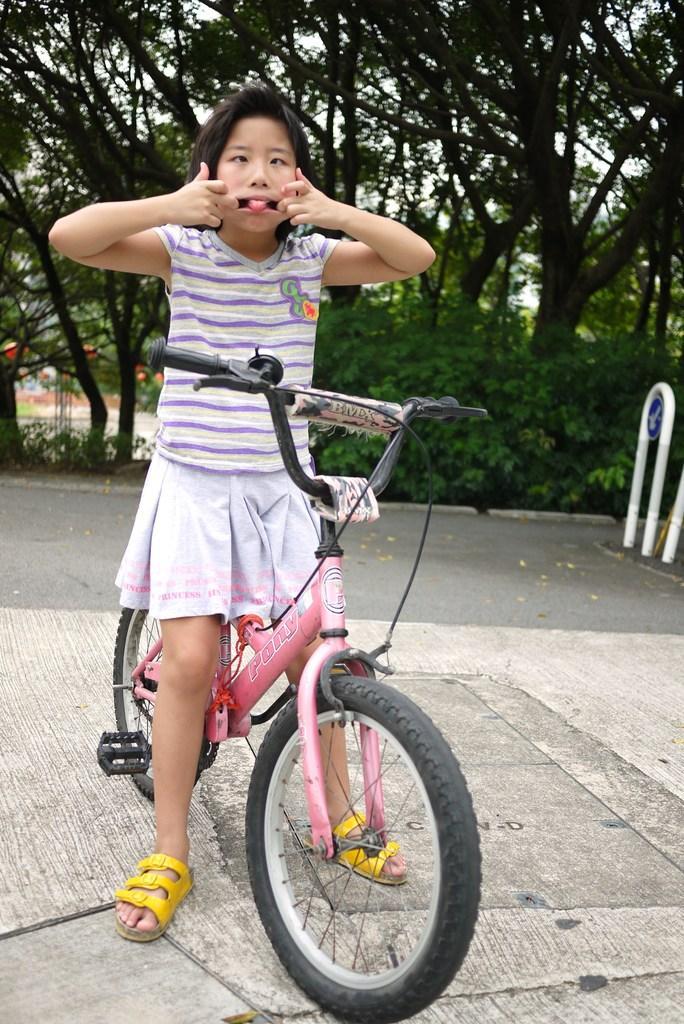How would you summarize this image in a sentence or two? There is a girl standing at the bicycle on a road and pulling her mouth open with her hands. behind the girl there are so many trees at back. 